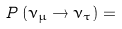Convert formula to latex. <formula><loc_0><loc_0><loc_500><loc_500>P \left ( \nu _ { \mu } \rightarrow \nu _ { \tau } \right ) =</formula> 